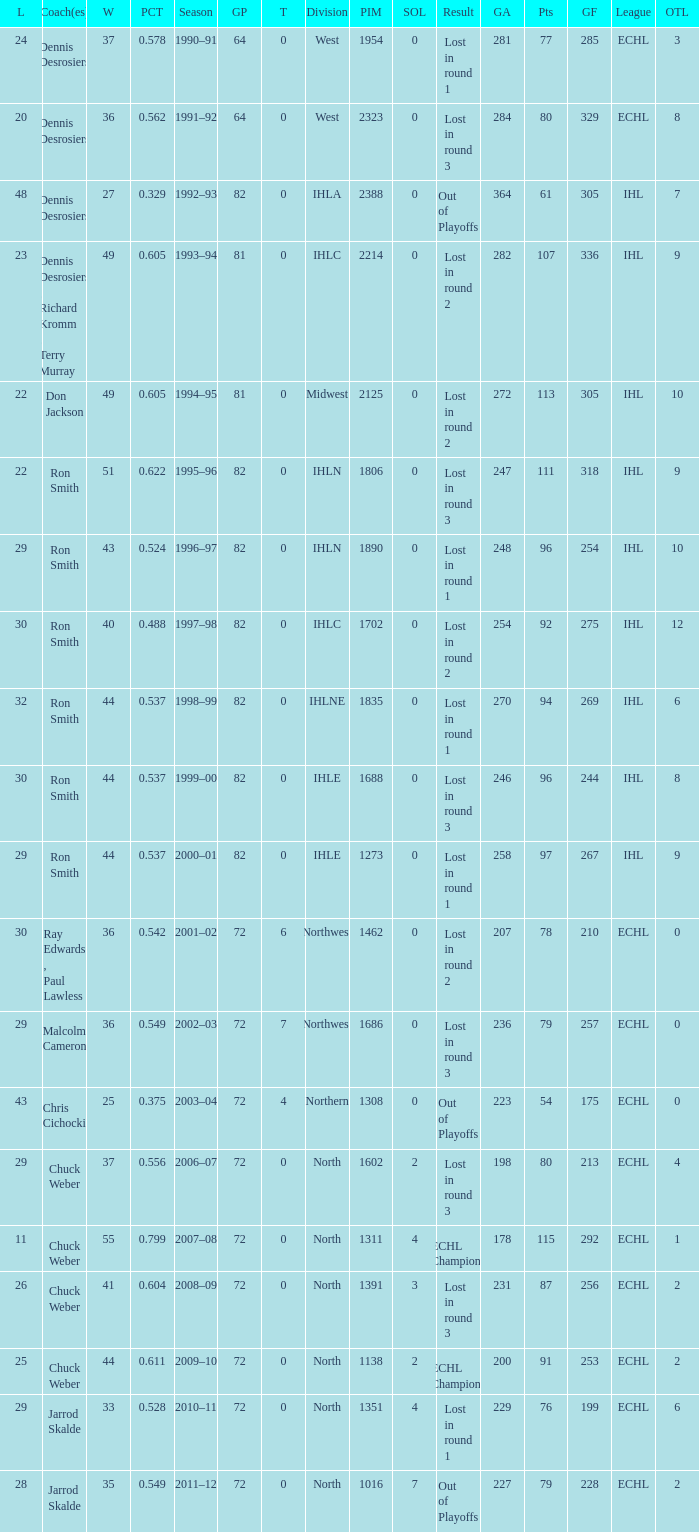What was the highest SOL where the team lost in round 3? 3.0. 